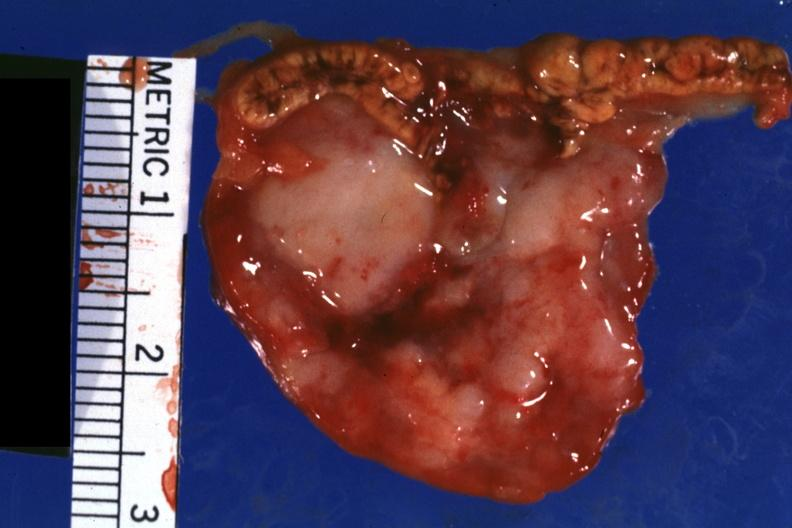what is present?
Answer the question using a single word or phrase. Metastatic carcinoma oat cell 